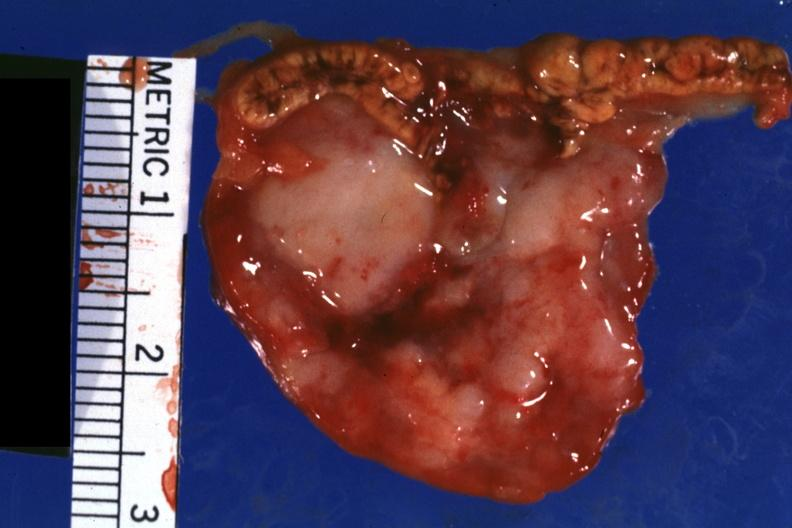what is present?
Answer the question using a single word or phrase. Metastatic carcinoma oat cell 